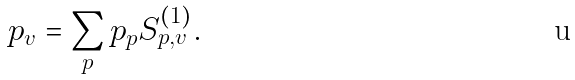Convert formula to latex. <formula><loc_0><loc_0><loc_500><loc_500>p _ { v } = \sum _ { p } p _ { p } S ^ { ( 1 ) } _ { p , v } .</formula> 